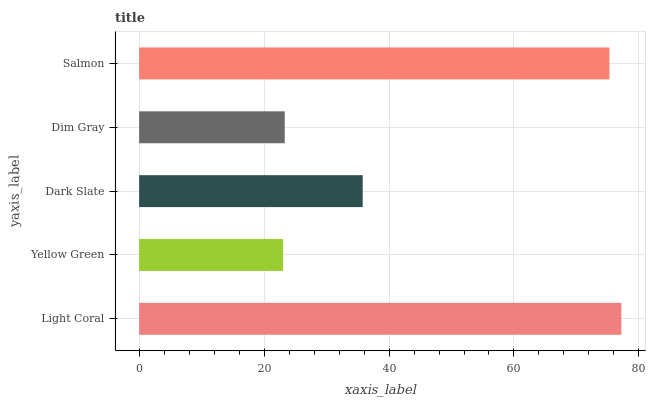Is Yellow Green the minimum?
Answer yes or no. Yes. Is Light Coral the maximum?
Answer yes or no. Yes. Is Dark Slate the minimum?
Answer yes or no. No. Is Dark Slate the maximum?
Answer yes or no. No. Is Dark Slate greater than Yellow Green?
Answer yes or no. Yes. Is Yellow Green less than Dark Slate?
Answer yes or no. Yes. Is Yellow Green greater than Dark Slate?
Answer yes or no. No. Is Dark Slate less than Yellow Green?
Answer yes or no. No. Is Dark Slate the high median?
Answer yes or no. Yes. Is Dark Slate the low median?
Answer yes or no. Yes. Is Yellow Green the high median?
Answer yes or no. No. Is Salmon the low median?
Answer yes or no. No. 